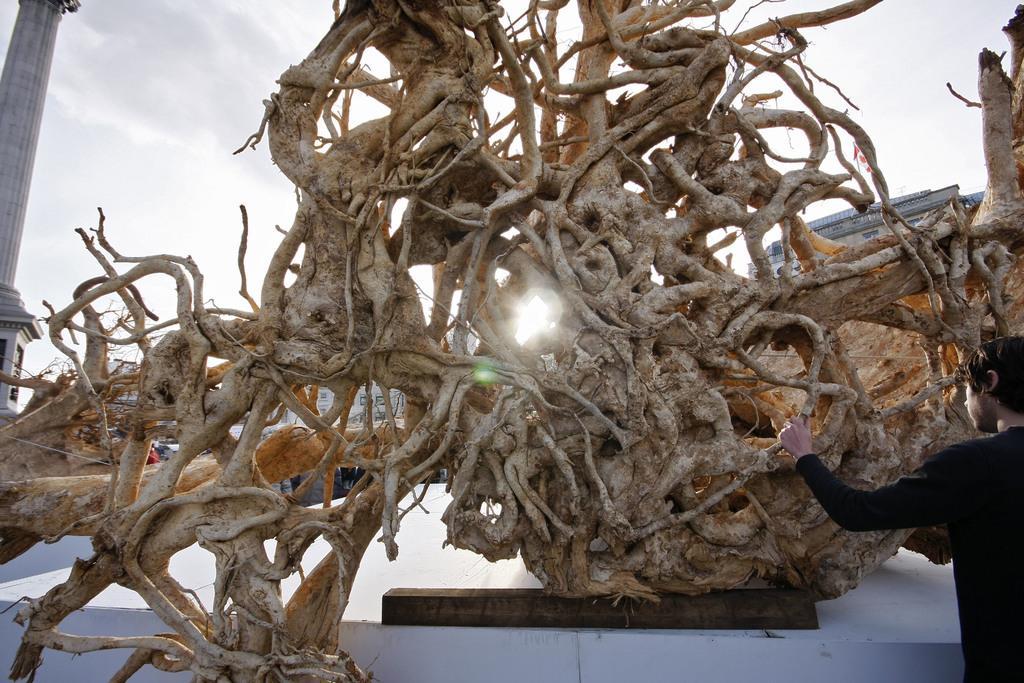Describe this image in one or two sentences. In this picture I can see there is a tree and it has no leaves, there is a person standing on the left side and there is a pillar at left side and the sky is clear. 